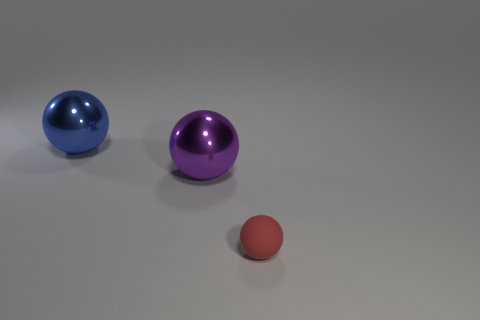Add 1 large red blocks. How many objects exist? 4 Add 1 big metal things. How many big metal things are left? 3 Add 1 yellow rubber spheres. How many yellow rubber spheres exist? 1 Subtract 0 purple cylinders. How many objects are left? 3 Subtract all small red matte spheres. Subtract all yellow objects. How many objects are left? 2 